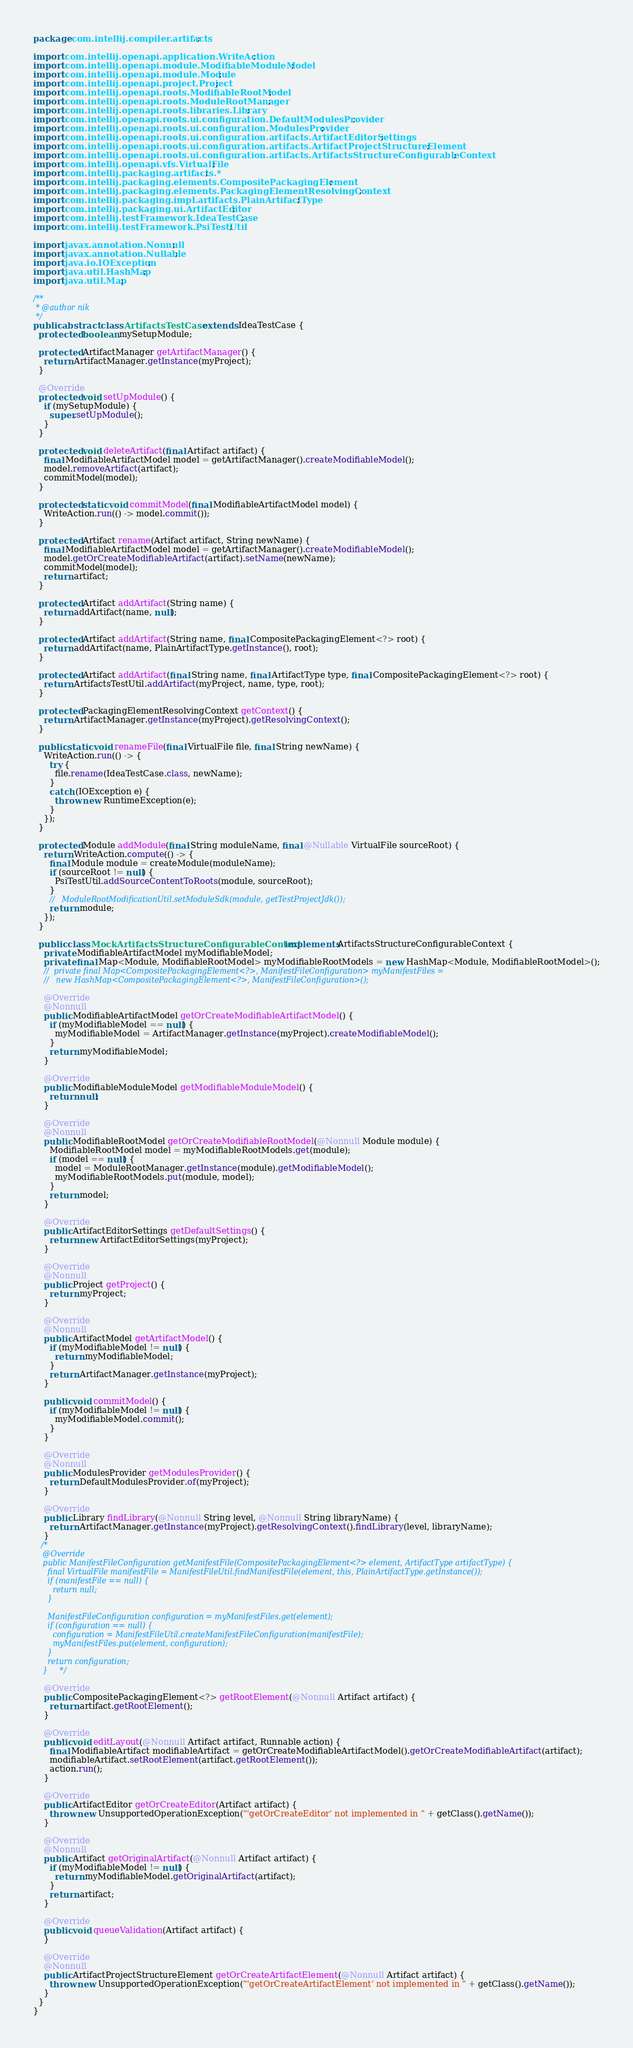<code> <loc_0><loc_0><loc_500><loc_500><_Java_>package com.intellij.compiler.artifacts;

import com.intellij.openapi.application.WriteAction;
import com.intellij.openapi.module.ModifiableModuleModel;
import com.intellij.openapi.module.Module;
import com.intellij.openapi.project.Project;
import com.intellij.openapi.roots.ModifiableRootModel;
import com.intellij.openapi.roots.ModuleRootManager;
import com.intellij.openapi.roots.libraries.Library;
import com.intellij.openapi.roots.ui.configuration.DefaultModulesProvider;
import com.intellij.openapi.roots.ui.configuration.ModulesProvider;
import com.intellij.openapi.roots.ui.configuration.artifacts.ArtifactEditorSettings;
import com.intellij.openapi.roots.ui.configuration.artifacts.ArtifactProjectStructureElement;
import com.intellij.openapi.roots.ui.configuration.artifacts.ArtifactsStructureConfigurableContext;
import com.intellij.openapi.vfs.VirtualFile;
import com.intellij.packaging.artifacts.*;
import com.intellij.packaging.elements.CompositePackagingElement;
import com.intellij.packaging.elements.PackagingElementResolvingContext;
import com.intellij.packaging.impl.artifacts.PlainArtifactType;
import com.intellij.packaging.ui.ArtifactEditor;
import com.intellij.testFramework.IdeaTestCase;
import com.intellij.testFramework.PsiTestUtil;

import javax.annotation.Nonnull;
import javax.annotation.Nullable;
import java.io.IOException;
import java.util.HashMap;
import java.util.Map;

/**
 * @author nik
 */
public abstract class ArtifactsTestCase extends IdeaTestCase {
  protected boolean mySetupModule;

  protected ArtifactManager getArtifactManager() {
    return ArtifactManager.getInstance(myProject);
  }

  @Override
  protected void setUpModule() {
    if (mySetupModule) {
      super.setUpModule();
    }
  }

  protected void deleteArtifact(final Artifact artifact) {
    final ModifiableArtifactModel model = getArtifactManager().createModifiableModel();
    model.removeArtifact(artifact);
    commitModel(model);
  }

  protected static void commitModel(final ModifiableArtifactModel model) {
    WriteAction.run(() -> model.commit());
  }

  protected Artifact rename(Artifact artifact, String newName) {
    final ModifiableArtifactModel model = getArtifactManager().createModifiableModel();
    model.getOrCreateModifiableArtifact(artifact).setName(newName);
    commitModel(model);
    return artifact;
  }

  protected Artifact addArtifact(String name) {
    return addArtifact(name, null);
  }

  protected Artifact addArtifact(String name, final CompositePackagingElement<?> root) {
    return addArtifact(name, PlainArtifactType.getInstance(), root);
  }

  protected Artifact addArtifact(final String name, final ArtifactType type, final CompositePackagingElement<?> root) {
    return ArtifactsTestUtil.addArtifact(myProject, name, type, root);
  }

  protected PackagingElementResolvingContext getContext() {
    return ArtifactManager.getInstance(myProject).getResolvingContext();
  }

  public static void renameFile(final VirtualFile file, final String newName) {
    WriteAction.run(() -> {
      try {
        file.rename(IdeaTestCase.class, newName);
      }
      catch (IOException e) {
        throw new RuntimeException(e);
      }
    });
  }

  protected Module addModule(final String moduleName, final @Nullable VirtualFile sourceRoot) {
    return WriteAction.compute(() -> {
      final Module module = createModule(moduleName);
      if (sourceRoot != null) {
        PsiTestUtil.addSourceContentToRoots(module, sourceRoot);
      }
      //   ModuleRootModificationUtil.setModuleSdk(module, getTestProjectJdk());
      return module;
    });
  }

  public class MockArtifactsStructureConfigurableContext implements ArtifactsStructureConfigurableContext {
    private ModifiableArtifactModel myModifiableModel;
    private final Map<Module, ModifiableRootModel> myModifiableRootModels = new HashMap<Module, ModifiableRootModel>();
    //  private final Map<CompositePackagingElement<?>, ManifestFileConfiguration> myManifestFiles =
    //   new HashMap<CompositePackagingElement<?>, ManifestFileConfiguration>();

    @Override
    @Nonnull
    public ModifiableArtifactModel getOrCreateModifiableArtifactModel() {
      if (myModifiableModel == null) {
        myModifiableModel = ArtifactManager.getInstance(myProject).createModifiableModel();
      }
      return myModifiableModel;
    }

    @Override
    public ModifiableModuleModel getModifiableModuleModel() {
      return null;
    }

    @Override
    @Nonnull
    public ModifiableRootModel getOrCreateModifiableRootModel(@Nonnull Module module) {
      ModifiableRootModel model = myModifiableRootModels.get(module);
      if (model == null) {
        model = ModuleRootManager.getInstance(module).getModifiableModel();
        myModifiableRootModels.put(module, model);
      }
      return model;
    }

    @Override
    public ArtifactEditorSettings getDefaultSettings() {
      return new ArtifactEditorSettings(myProject);
    }

    @Override
    @Nonnull
    public Project getProject() {
      return myProject;
    }

    @Override
    @Nonnull
    public ArtifactModel getArtifactModel() {
      if (myModifiableModel != null) {
        return myModifiableModel;
      }
      return ArtifactManager.getInstance(myProject);
    }

    public void commitModel() {
      if (myModifiableModel != null) {
        myModifiableModel.commit();
      }
    }

    @Override
    @Nonnull
    public ModulesProvider getModulesProvider() {
      return DefaultModulesProvider.of(myProject);
    }

    @Override
    public Library findLibrary(@Nonnull String level, @Nonnull String libraryName) {
      return ArtifactManager.getInstance(myProject).getResolvingContext().findLibrary(level, libraryName);
    }
   /*
    @Override
    public ManifestFileConfiguration getManifestFile(CompositePackagingElement<?> element, ArtifactType artifactType) {
      final VirtualFile manifestFile = ManifestFileUtil.findManifestFile(element, this, PlainArtifactType.getInstance());
      if (manifestFile == null) {
        return null;
      }

      ManifestFileConfiguration configuration = myManifestFiles.get(element);
      if (configuration == null) {
        configuration = ManifestFileUtil.createManifestFileConfiguration(manifestFile);
        myManifestFiles.put(element, configuration);
      }
      return configuration;
    }     */

    @Override
    public CompositePackagingElement<?> getRootElement(@Nonnull Artifact artifact) {
      return artifact.getRootElement();
    }

    @Override
    public void editLayout(@Nonnull Artifact artifact, Runnable action) {
      final ModifiableArtifact modifiableArtifact = getOrCreateModifiableArtifactModel().getOrCreateModifiableArtifact(artifact);
      modifiableArtifact.setRootElement(artifact.getRootElement());
      action.run();
    }

    @Override
    public ArtifactEditor getOrCreateEditor(Artifact artifact) {
      throw new UnsupportedOperationException("'getOrCreateEditor' not implemented in " + getClass().getName());
    }

    @Override
    @Nonnull
    public Artifact getOriginalArtifact(@Nonnull Artifact artifact) {
      if (myModifiableModel != null) {
        return myModifiableModel.getOriginalArtifact(artifact);
      }
      return artifact;
    }

    @Override
    public void queueValidation(Artifact artifact) {
    }

    @Override
    @Nonnull
    public ArtifactProjectStructureElement getOrCreateArtifactElement(@Nonnull Artifact artifact) {
      throw new UnsupportedOperationException("'getOrCreateArtifactElement' not implemented in " + getClass().getName());
    }
  }
}
</code> 